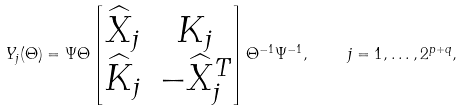<formula> <loc_0><loc_0><loc_500><loc_500>Y _ { j } ( \Theta ) = \Psi \Theta \begin{bmatrix} \widehat { X } _ { j } & K _ { j } \\ \widehat { K } _ { j } & - \widehat { X } _ { j } ^ { T } \end{bmatrix} \Theta ^ { - 1 } \Psi ^ { - 1 } , \quad j = 1 , \dots , 2 ^ { p + q } ,</formula> 